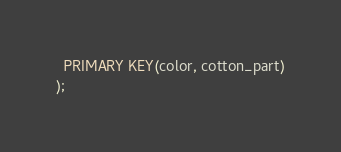Convert code to text. <code><loc_0><loc_0><loc_500><loc_500><_SQL_>  PRIMARY KEY(color, cotton_part)
);</code> 